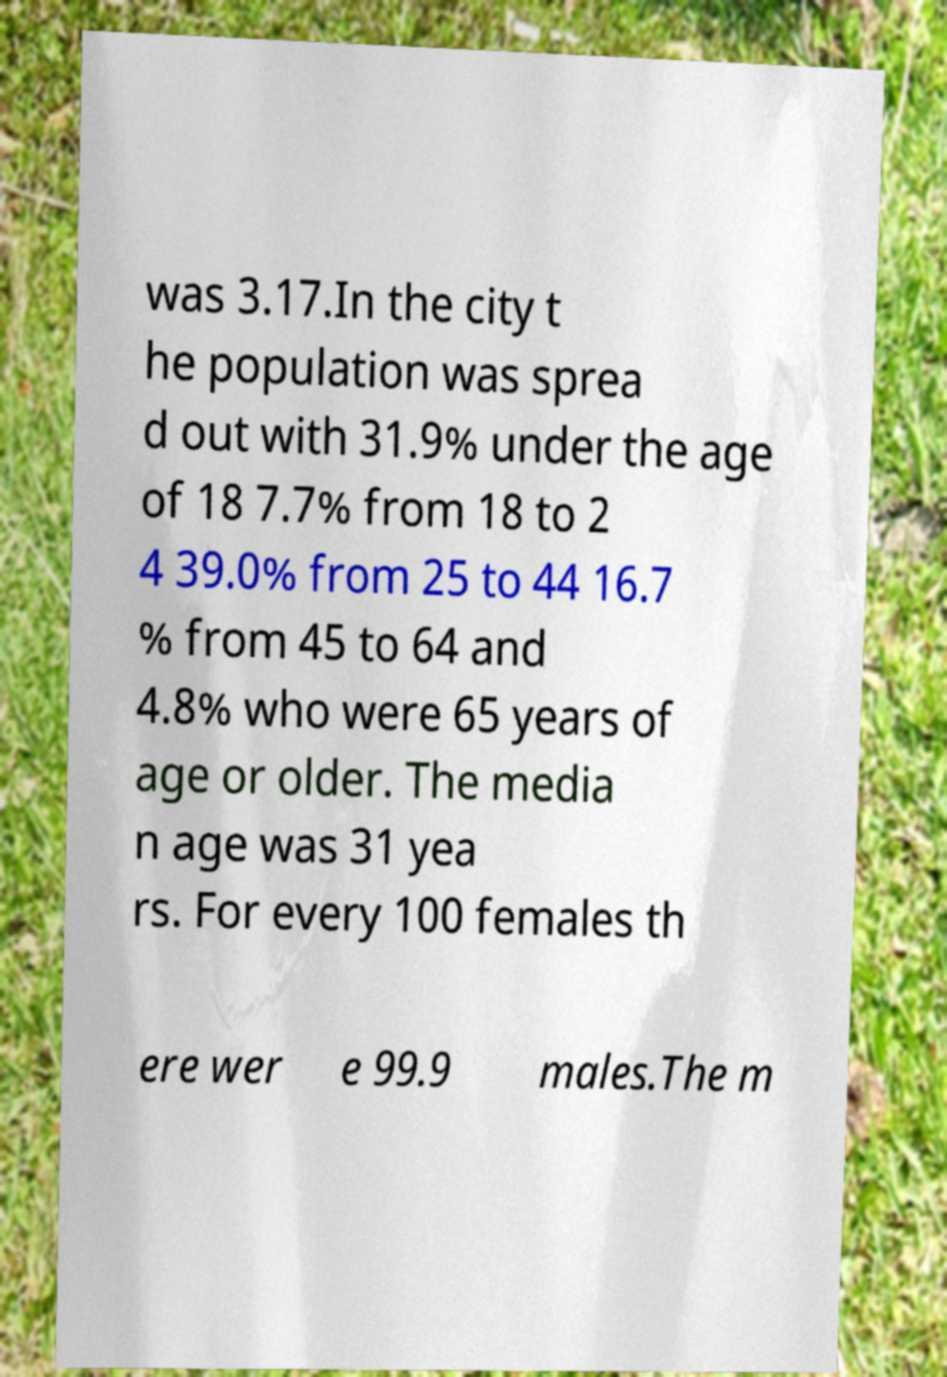Can you read and provide the text displayed in the image?This photo seems to have some interesting text. Can you extract and type it out for me? was 3.17.In the city t he population was sprea d out with 31.9% under the age of 18 7.7% from 18 to 2 4 39.0% from 25 to 44 16.7 % from 45 to 64 and 4.8% who were 65 years of age or older. The media n age was 31 yea rs. For every 100 females th ere wer e 99.9 males.The m 